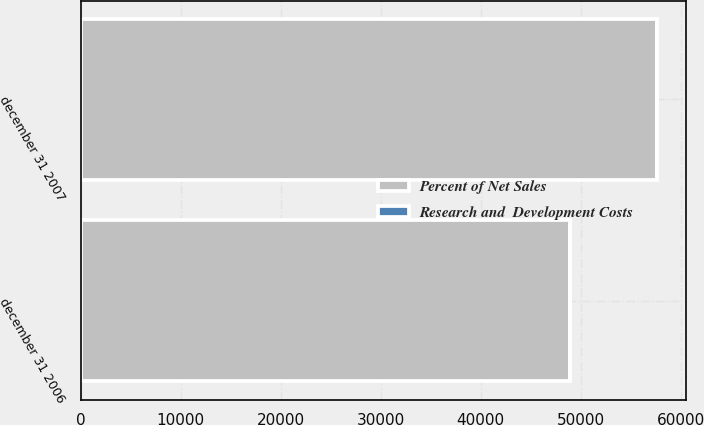Convert chart. <chart><loc_0><loc_0><loc_500><loc_500><stacked_bar_chart><ecel><fcel>december 31 2007<fcel>december 31 2006<nl><fcel>Percent of Net Sales<fcel>57600<fcel>48959<nl><fcel>Research and  Development Costs<fcel>6.6<fcel>6.4<nl></chart> 